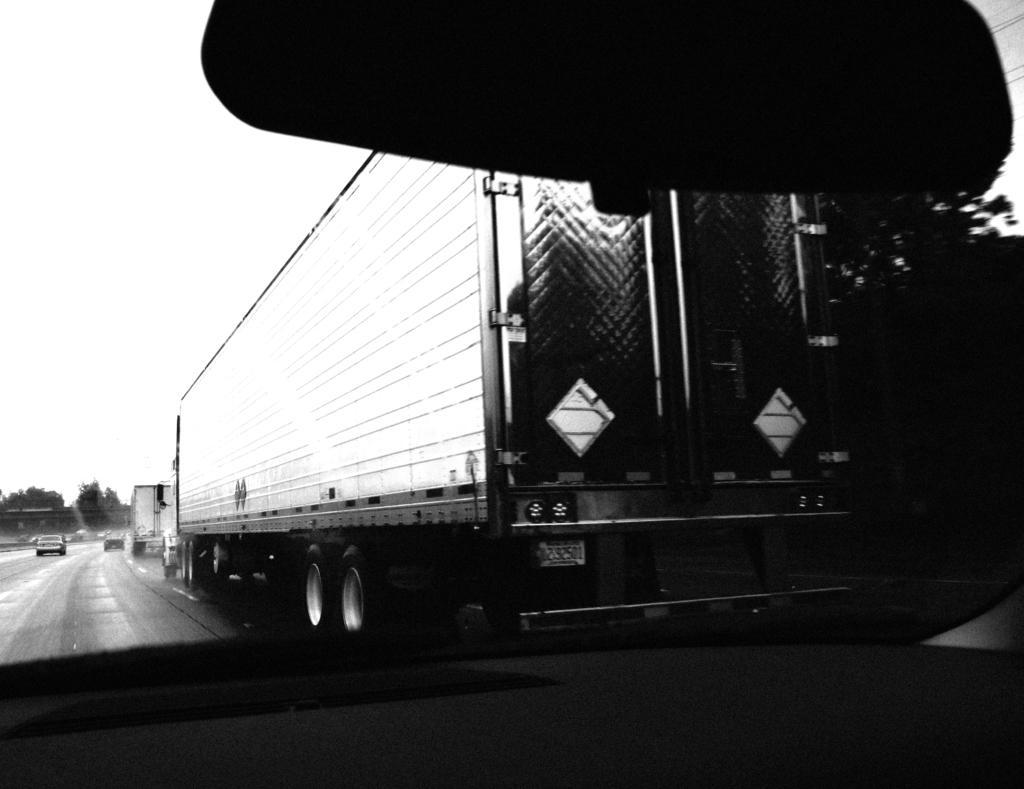How would you summarize this image in a sentence or two? This picture is a black and white image. In this image we can see through the car glass, one black object at the top of the image, some trees, some vehicles on the road, one object in the car, right side of the image is dark, the background is blurred and at the top there is the sky. 